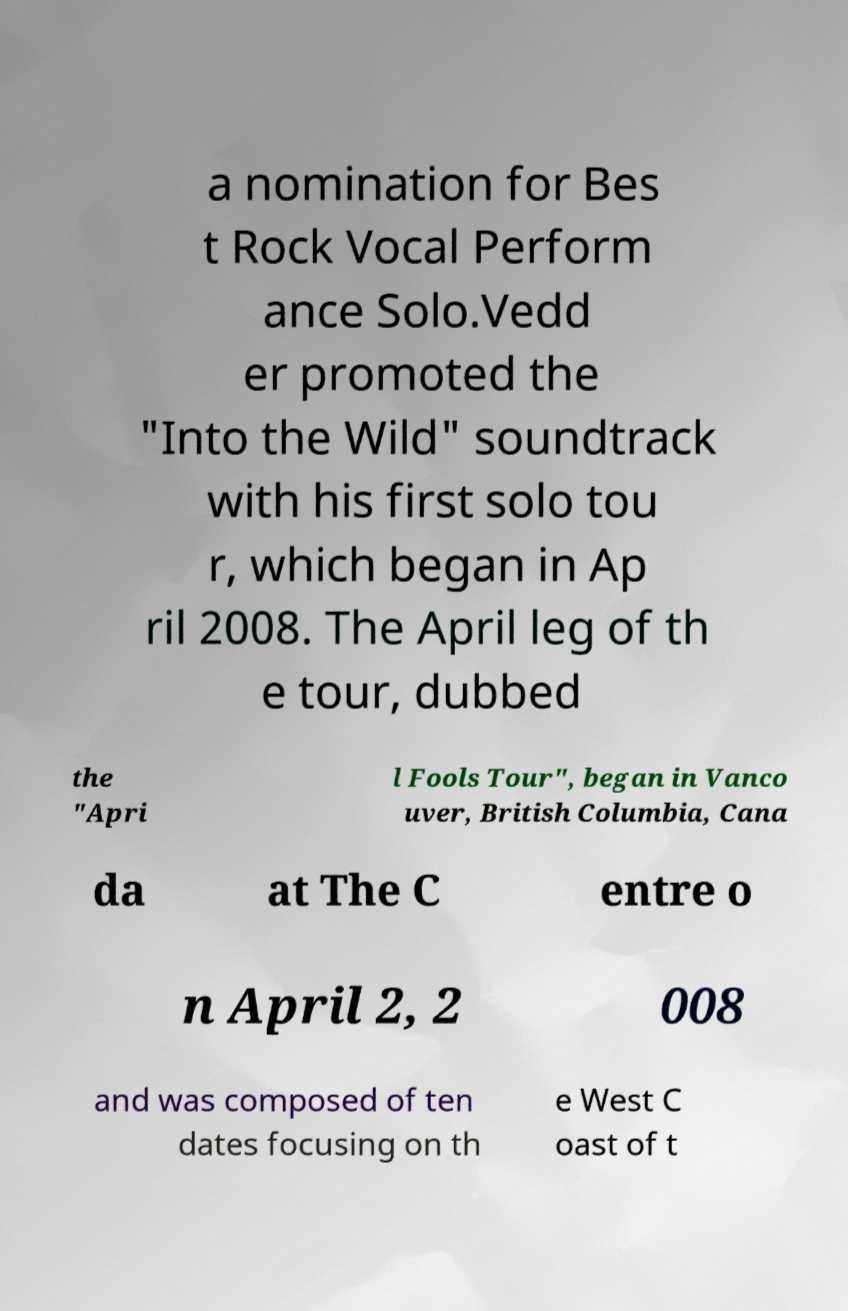Please identify and transcribe the text found in this image. a nomination for Bes t Rock Vocal Perform ance Solo.Vedd er promoted the "Into the Wild" soundtrack with his first solo tou r, which began in Ap ril 2008. The April leg of th e tour, dubbed the "Apri l Fools Tour", began in Vanco uver, British Columbia, Cana da at The C entre o n April 2, 2 008 and was composed of ten dates focusing on th e West C oast of t 